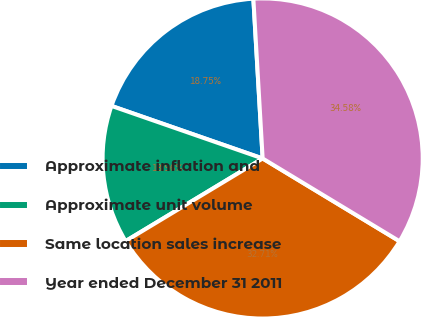Convert chart to OTSL. <chart><loc_0><loc_0><loc_500><loc_500><pie_chart><fcel>Approximate inflation and<fcel>Approximate unit volume<fcel>Same location sales increase<fcel>Year ended December 31 2011<nl><fcel>18.75%<fcel>13.96%<fcel>32.71%<fcel>34.58%<nl></chart> 